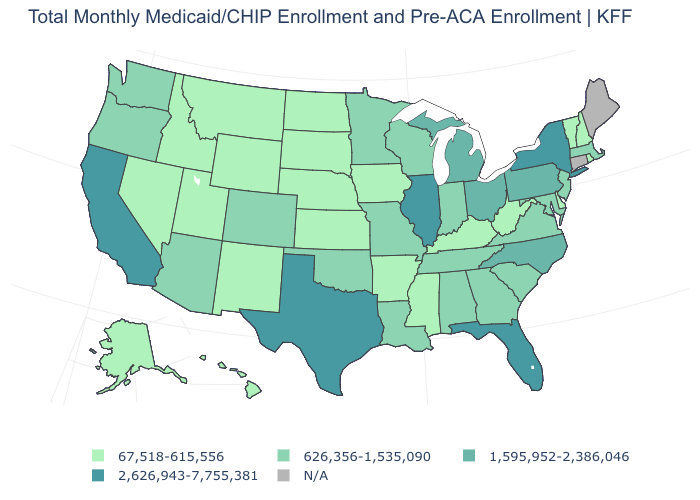Does the map have missing data?
Answer briefly. Yes. What is the value of New Hampshire?
Short answer required. 67,518-615,556. Which states have the lowest value in the USA?
Answer briefly. Alaska, Arkansas, Delaware, Hawaii, Idaho, Iowa, Kansas, Kentucky, Mississippi, Montana, Nebraska, Nevada, New Hampshire, New Mexico, North Dakota, Rhode Island, South Dakota, Utah, Vermont, West Virginia, Wyoming. What is the value of Oklahoma?
Give a very brief answer. 626,356-1,535,090. Name the states that have a value in the range 67,518-615,556?
Answer briefly. Alaska, Arkansas, Delaware, Hawaii, Idaho, Iowa, Kansas, Kentucky, Mississippi, Montana, Nebraska, Nevada, New Hampshire, New Mexico, North Dakota, Rhode Island, South Dakota, Utah, Vermont, West Virginia, Wyoming. Which states have the lowest value in the USA?
Concise answer only. Alaska, Arkansas, Delaware, Hawaii, Idaho, Iowa, Kansas, Kentucky, Mississippi, Montana, Nebraska, Nevada, New Hampshire, New Mexico, North Dakota, Rhode Island, South Dakota, Utah, Vermont, West Virginia, Wyoming. Does the map have missing data?
Write a very short answer. Yes. What is the value of California?
Give a very brief answer. 2,626,943-7,755,381. Among the states that border Indiana , does Kentucky have the highest value?
Short answer required. No. Which states hav the highest value in the West?
Quick response, please. California. What is the lowest value in the MidWest?
Concise answer only. 67,518-615,556. Name the states that have a value in the range 1,595,952-2,386,046?
Give a very brief answer. Michigan, North Carolina, Ohio, Pennsylvania. Which states have the lowest value in the USA?
Keep it brief. Alaska, Arkansas, Delaware, Hawaii, Idaho, Iowa, Kansas, Kentucky, Mississippi, Montana, Nebraska, Nevada, New Hampshire, New Mexico, North Dakota, Rhode Island, South Dakota, Utah, Vermont, West Virginia, Wyoming. Name the states that have a value in the range 1,595,952-2,386,046?
Short answer required. Michigan, North Carolina, Ohio, Pennsylvania. What is the lowest value in the USA?
Keep it brief. 67,518-615,556. 